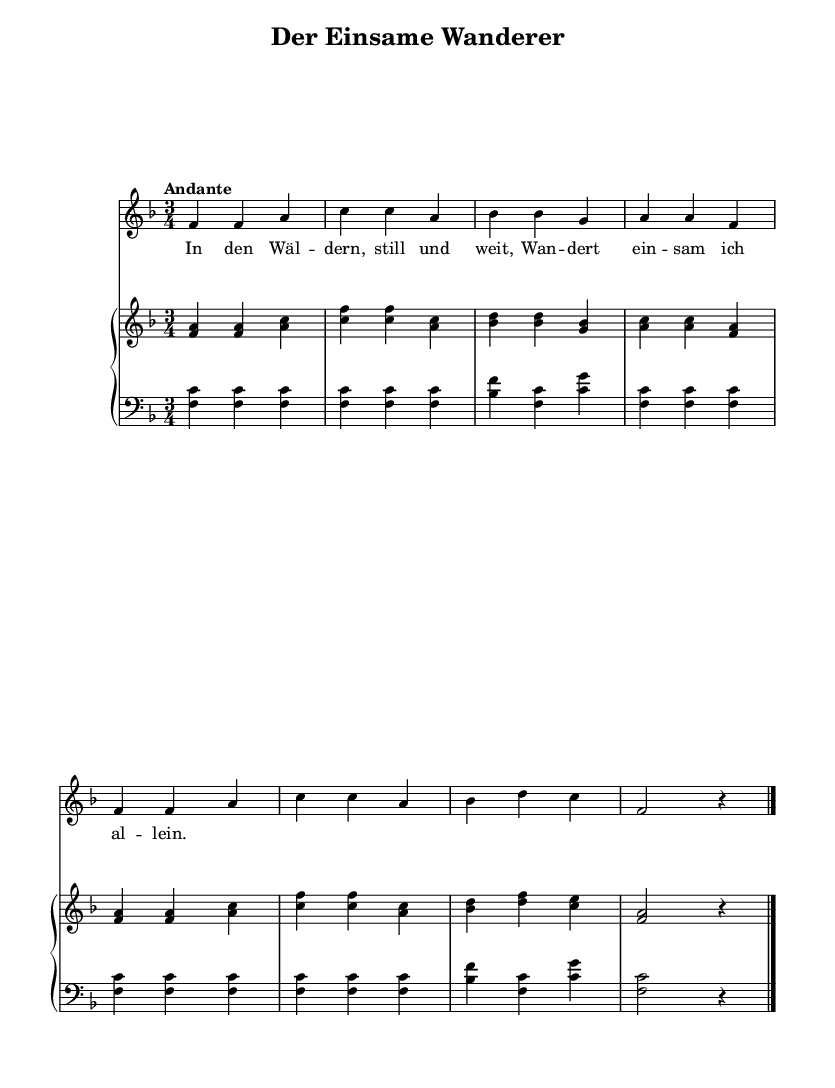What is the key signature of this music? The key signature indicates that there is one flat, which signifies that the music is in F major.
Answer: F major What is the time signature of this piece? The time signature is indicated at the beginning of the sheet music and shows a 3/4 rhythm, meaning there are three beats per measure.
Answer: 3/4 What is the tempo marking for this song? The tempo marking "Andante" suggests a moderate pace, typically around 76 to 108 beats per minute.
Answer: Andante How many measures are in the piece? By counting the groupings of bars (and noticing the bar lines), there are a total of 8 measures in the music.
Answer: 8 What is the dynamic marking for the vocal part? The dynamic marking is indicated clearly in the score and specifies to use the "dynamicUp" instruction for the vocal part, which typically indicates a softer dynamic.
Answer: dynamicUp What kind of musical form is primarily used in this folk song? Analyzing the structure, the piece clearly follows a strophic form, where the same music is repeated with different lyrics.
Answer: Strophic 